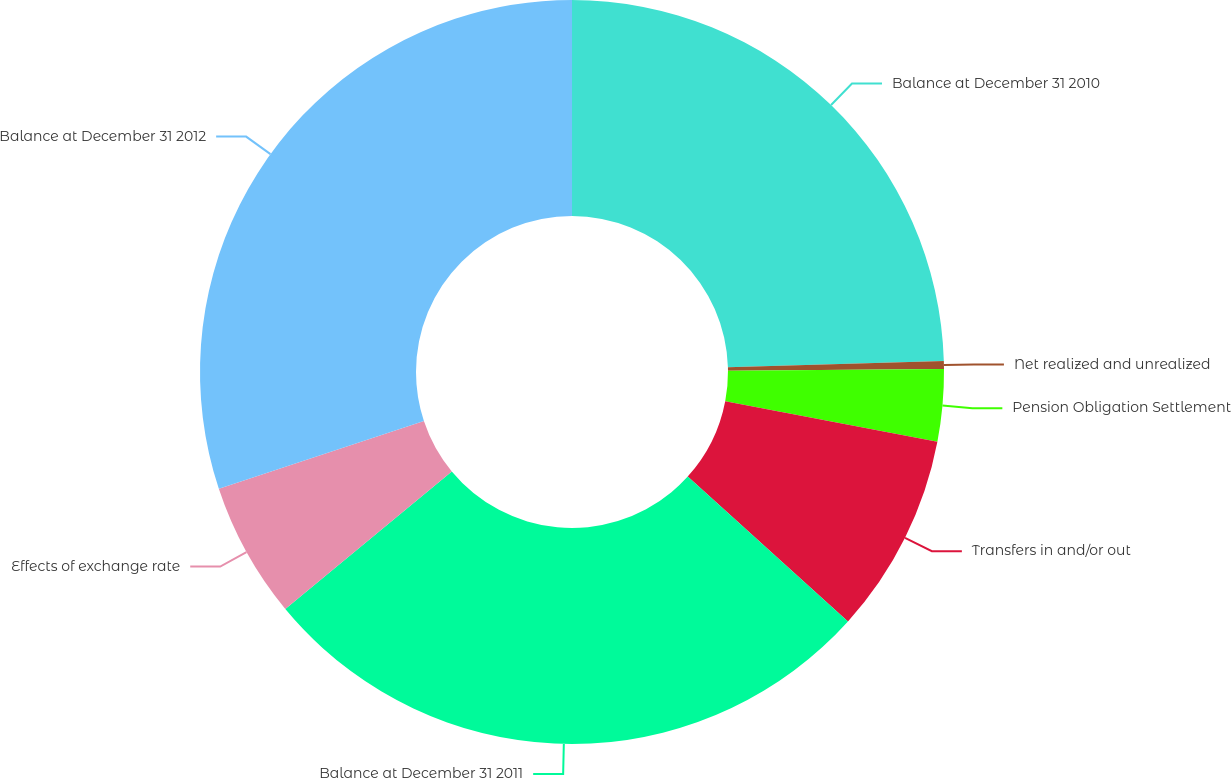Convert chart to OTSL. <chart><loc_0><loc_0><loc_500><loc_500><pie_chart><fcel>Balance at December 31 2010<fcel>Net realized and unrealized<fcel>Pension Obligation Settlement<fcel>Transfers in and/or out<fcel>Balance at December 31 2011<fcel>Effects of exchange rate<fcel>Balance at December 31 2012<nl><fcel>24.52%<fcel>0.35%<fcel>3.13%<fcel>8.69%<fcel>27.3%<fcel>5.91%<fcel>30.08%<nl></chart> 